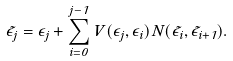<formula> <loc_0><loc_0><loc_500><loc_500>\tilde { \epsilon } _ { j } = \epsilon _ { j } + \sum _ { i = 0 } ^ { j - 1 } V ( \epsilon _ { j } , \epsilon _ { i } ) N ( \tilde { \epsilon } _ { i } , \tilde { \epsilon } _ { i + 1 } ) .</formula> 